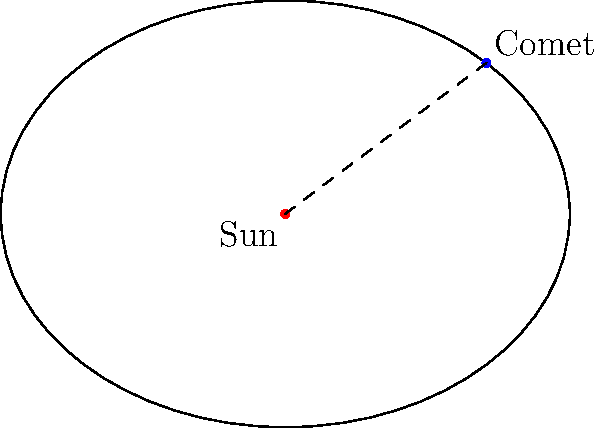In the diagram, a comet's orbit around the Sun is represented by an ellipse. The Sun is located at one of the foci (F). If the semi-major axis (a) is 4 AU and the semi-minor axis (b) is 3 AU, calculate the eccentricity (e) of the comet's orbit to two decimal places. To calculate the eccentricity of an elliptical orbit, we can follow these steps:

1. Recall the formula for eccentricity:
   $$e = \frac{c}{a}$$
   where $c$ is the distance from the center to a focus, and $a$ is the semi-major axis.

2. We know $a = 4$ AU, but we need to find $c$.

3. In an ellipse, $a$, $b$, and $c$ are related by the equation:
   $$a^2 = b^2 + c^2$$

4. Substitute the known values:
   $$4^2 = 3^2 + c^2$$

5. Solve for $c$:
   $$16 = 9 + c^2$$
   $$c^2 = 7$$
   $$c = \sqrt{7}$$

6. Now we can calculate the eccentricity:
   $$e = \frac{\sqrt{7}}{4}$$

7. Use a calculator to compute the decimal value:
   $$e \approx 0.6614$$

8. Rounding to two decimal places:
   $$e \approx 0.66$$
Answer: 0.66 